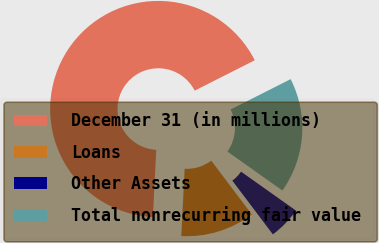<chart> <loc_0><loc_0><loc_500><loc_500><pie_chart><fcel>December 31 (in millions)<fcel>Loans<fcel>Other Assets<fcel>Total nonrecurring fair value<nl><fcel>66.75%<fcel>11.08%<fcel>4.9%<fcel>17.27%<nl></chart> 